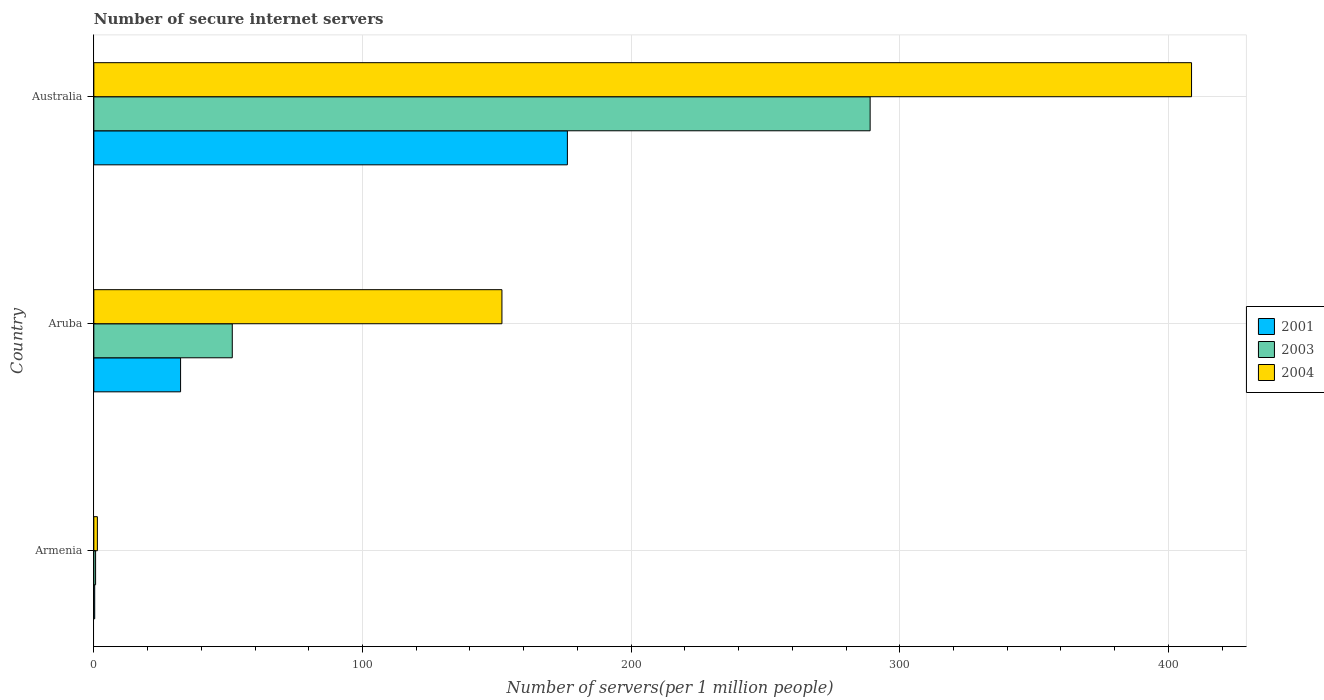Are the number of bars per tick equal to the number of legend labels?
Provide a succinct answer. Yes. How many bars are there on the 3rd tick from the top?
Give a very brief answer. 3. What is the label of the 3rd group of bars from the top?
Keep it short and to the point. Armenia. What is the number of secure internet servers in 2004 in Australia?
Give a very brief answer. 408.6. Across all countries, what is the maximum number of secure internet servers in 2001?
Ensure brevity in your answer.  176.27. Across all countries, what is the minimum number of secure internet servers in 2001?
Provide a short and direct response. 0.33. In which country was the number of secure internet servers in 2003 maximum?
Keep it short and to the point. Australia. In which country was the number of secure internet servers in 2001 minimum?
Give a very brief answer. Armenia. What is the total number of secure internet servers in 2003 in the graph?
Make the answer very short. 341.16. What is the difference between the number of secure internet servers in 2003 in Armenia and that in Aruba?
Make the answer very short. -50.88. What is the difference between the number of secure internet servers in 2003 in Aruba and the number of secure internet servers in 2004 in Armenia?
Offer a terse response. 50.22. What is the average number of secure internet servers in 2004 per country?
Ensure brevity in your answer.  187.28. What is the difference between the number of secure internet servers in 2003 and number of secure internet servers in 2004 in Armenia?
Offer a very short reply. -0.66. What is the ratio of the number of secure internet servers in 2001 in Armenia to that in Aruba?
Give a very brief answer. 0.01. Is the number of secure internet servers in 2004 in Aruba less than that in Australia?
Your answer should be compact. Yes. What is the difference between the highest and the second highest number of secure internet servers in 2004?
Your answer should be compact. 256.69. What is the difference between the highest and the lowest number of secure internet servers in 2001?
Your answer should be very brief. 175.95. Is the sum of the number of secure internet servers in 2003 in Aruba and Australia greater than the maximum number of secure internet servers in 2001 across all countries?
Keep it short and to the point. Yes. What does the 1st bar from the bottom in Aruba represents?
Ensure brevity in your answer.  2001. Is it the case that in every country, the sum of the number of secure internet servers in 2001 and number of secure internet servers in 2003 is greater than the number of secure internet servers in 2004?
Ensure brevity in your answer.  No. Are all the bars in the graph horizontal?
Offer a very short reply. Yes. What is the title of the graph?
Your answer should be compact. Number of secure internet servers. Does "2015" appear as one of the legend labels in the graph?
Ensure brevity in your answer.  No. What is the label or title of the X-axis?
Provide a succinct answer. Number of servers(per 1 million people). What is the Number of servers(per 1 million people) of 2001 in Armenia?
Make the answer very short. 0.33. What is the Number of servers(per 1 million people) in 2003 in Armenia?
Your response must be concise. 0.66. What is the Number of servers(per 1 million people) of 2004 in Armenia?
Give a very brief answer. 1.32. What is the Number of servers(per 1 million people) of 2001 in Aruba?
Keep it short and to the point. 32.29. What is the Number of servers(per 1 million people) of 2003 in Aruba?
Ensure brevity in your answer.  51.54. What is the Number of servers(per 1 million people) of 2004 in Aruba?
Give a very brief answer. 151.91. What is the Number of servers(per 1 million people) in 2001 in Australia?
Offer a terse response. 176.27. What is the Number of servers(per 1 million people) of 2003 in Australia?
Keep it short and to the point. 288.96. What is the Number of servers(per 1 million people) in 2004 in Australia?
Your answer should be compact. 408.6. Across all countries, what is the maximum Number of servers(per 1 million people) of 2001?
Offer a terse response. 176.27. Across all countries, what is the maximum Number of servers(per 1 million people) in 2003?
Make the answer very short. 288.96. Across all countries, what is the maximum Number of servers(per 1 million people) of 2004?
Provide a succinct answer. 408.6. Across all countries, what is the minimum Number of servers(per 1 million people) in 2001?
Ensure brevity in your answer.  0.33. Across all countries, what is the minimum Number of servers(per 1 million people) in 2003?
Provide a short and direct response. 0.66. Across all countries, what is the minimum Number of servers(per 1 million people) in 2004?
Your answer should be very brief. 1.32. What is the total Number of servers(per 1 million people) in 2001 in the graph?
Offer a very short reply. 208.9. What is the total Number of servers(per 1 million people) in 2003 in the graph?
Keep it short and to the point. 341.16. What is the total Number of servers(per 1 million people) in 2004 in the graph?
Your response must be concise. 561.83. What is the difference between the Number of servers(per 1 million people) of 2001 in Armenia and that in Aruba?
Ensure brevity in your answer.  -31.97. What is the difference between the Number of servers(per 1 million people) of 2003 in Armenia and that in Aruba?
Provide a succinct answer. -50.88. What is the difference between the Number of servers(per 1 million people) in 2004 in Armenia and that in Aruba?
Provide a short and direct response. -150.59. What is the difference between the Number of servers(per 1 million people) of 2001 in Armenia and that in Australia?
Your response must be concise. -175.95. What is the difference between the Number of servers(per 1 million people) in 2003 in Armenia and that in Australia?
Provide a succinct answer. -288.3. What is the difference between the Number of servers(per 1 million people) of 2004 in Armenia and that in Australia?
Provide a short and direct response. -407.28. What is the difference between the Number of servers(per 1 million people) in 2001 in Aruba and that in Australia?
Make the answer very short. -143.98. What is the difference between the Number of servers(per 1 million people) in 2003 in Aruba and that in Australia?
Your answer should be compact. -237.42. What is the difference between the Number of servers(per 1 million people) in 2004 in Aruba and that in Australia?
Offer a terse response. -256.69. What is the difference between the Number of servers(per 1 million people) of 2001 in Armenia and the Number of servers(per 1 million people) of 2003 in Aruba?
Make the answer very short. -51.21. What is the difference between the Number of servers(per 1 million people) of 2001 in Armenia and the Number of servers(per 1 million people) of 2004 in Aruba?
Your answer should be compact. -151.58. What is the difference between the Number of servers(per 1 million people) in 2003 in Armenia and the Number of servers(per 1 million people) in 2004 in Aruba?
Offer a terse response. -151.25. What is the difference between the Number of servers(per 1 million people) of 2001 in Armenia and the Number of servers(per 1 million people) of 2003 in Australia?
Keep it short and to the point. -288.63. What is the difference between the Number of servers(per 1 million people) in 2001 in Armenia and the Number of servers(per 1 million people) in 2004 in Australia?
Your response must be concise. -408.27. What is the difference between the Number of servers(per 1 million people) in 2003 in Armenia and the Number of servers(per 1 million people) in 2004 in Australia?
Ensure brevity in your answer.  -407.94. What is the difference between the Number of servers(per 1 million people) in 2001 in Aruba and the Number of servers(per 1 million people) in 2003 in Australia?
Offer a very short reply. -256.67. What is the difference between the Number of servers(per 1 million people) of 2001 in Aruba and the Number of servers(per 1 million people) of 2004 in Australia?
Ensure brevity in your answer.  -376.3. What is the difference between the Number of servers(per 1 million people) of 2003 in Aruba and the Number of servers(per 1 million people) of 2004 in Australia?
Your response must be concise. -357.06. What is the average Number of servers(per 1 million people) of 2001 per country?
Offer a very short reply. 69.63. What is the average Number of servers(per 1 million people) in 2003 per country?
Offer a very short reply. 113.72. What is the average Number of servers(per 1 million people) of 2004 per country?
Offer a very short reply. 187.28. What is the difference between the Number of servers(per 1 million people) in 2001 and Number of servers(per 1 million people) in 2003 in Armenia?
Make the answer very short. -0.33. What is the difference between the Number of servers(per 1 million people) of 2001 and Number of servers(per 1 million people) of 2004 in Armenia?
Keep it short and to the point. -1. What is the difference between the Number of servers(per 1 million people) of 2003 and Number of servers(per 1 million people) of 2004 in Armenia?
Your answer should be compact. -0.66. What is the difference between the Number of servers(per 1 million people) in 2001 and Number of servers(per 1 million people) in 2003 in Aruba?
Your response must be concise. -19.24. What is the difference between the Number of servers(per 1 million people) in 2001 and Number of servers(per 1 million people) in 2004 in Aruba?
Offer a terse response. -119.62. What is the difference between the Number of servers(per 1 million people) of 2003 and Number of servers(per 1 million people) of 2004 in Aruba?
Your answer should be very brief. -100.37. What is the difference between the Number of servers(per 1 million people) in 2001 and Number of servers(per 1 million people) in 2003 in Australia?
Provide a succinct answer. -112.69. What is the difference between the Number of servers(per 1 million people) in 2001 and Number of servers(per 1 million people) in 2004 in Australia?
Give a very brief answer. -232.32. What is the difference between the Number of servers(per 1 million people) of 2003 and Number of servers(per 1 million people) of 2004 in Australia?
Your response must be concise. -119.64. What is the ratio of the Number of servers(per 1 million people) of 2001 in Armenia to that in Aruba?
Provide a succinct answer. 0.01. What is the ratio of the Number of servers(per 1 million people) in 2003 in Armenia to that in Aruba?
Your response must be concise. 0.01. What is the ratio of the Number of servers(per 1 million people) in 2004 in Armenia to that in Aruba?
Your answer should be compact. 0.01. What is the ratio of the Number of servers(per 1 million people) in 2001 in Armenia to that in Australia?
Give a very brief answer. 0. What is the ratio of the Number of servers(per 1 million people) of 2003 in Armenia to that in Australia?
Ensure brevity in your answer.  0. What is the ratio of the Number of servers(per 1 million people) of 2004 in Armenia to that in Australia?
Make the answer very short. 0. What is the ratio of the Number of servers(per 1 million people) in 2001 in Aruba to that in Australia?
Your answer should be compact. 0.18. What is the ratio of the Number of servers(per 1 million people) in 2003 in Aruba to that in Australia?
Offer a terse response. 0.18. What is the ratio of the Number of servers(per 1 million people) of 2004 in Aruba to that in Australia?
Give a very brief answer. 0.37. What is the difference between the highest and the second highest Number of servers(per 1 million people) of 2001?
Provide a succinct answer. 143.98. What is the difference between the highest and the second highest Number of servers(per 1 million people) of 2003?
Provide a short and direct response. 237.42. What is the difference between the highest and the second highest Number of servers(per 1 million people) in 2004?
Offer a very short reply. 256.69. What is the difference between the highest and the lowest Number of servers(per 1 million people) in 2001?
Make the answer very short. 175.95. What is the difference between the highest and the lowest Number of servers(per 1 million people) in 2003?
Ensure brevity in your answer.  288.3. What is the difference between the highest and the lowest Number of servers(per 1 million people) of 2004?
Your answer should be compact. 407.28. 